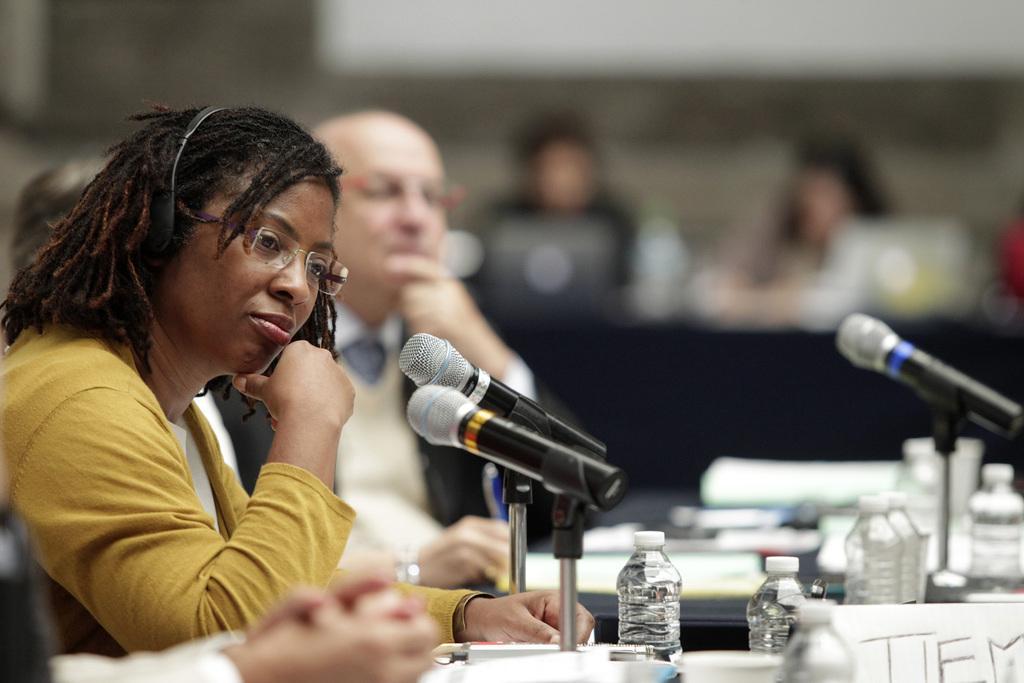How would you summarize this image in a sentence or two? This picture might be taken inside a conference hall. In this image, on the left side, we can see a group of people sitting on the chair in front of the table. On that table, we can see some microphones, water bottle. In the background, we can also see a group of people sitting on the chair in front of the table and a white color board. 